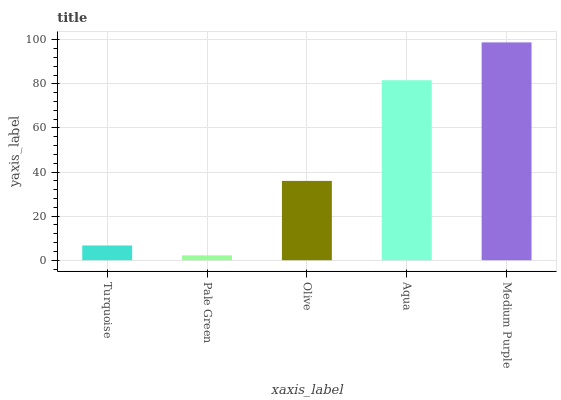Is Pale Green the minimum?
Answer yes or no. Yes. Is Medium Purple the maximum?
Answer yes or no. Yes. Is Olive the minimum?
Answer yes or no. No. Is Olive the maximum?
Answer yes or no. No. Is Olive greater than Pale Green?
Answer yes or no. Yes. Is Pale Green less than Olive?
Answer yes or no. Yes. Is Pale Green greater than Olive?
Answer yes or no. No. Is Olive less than Pale Green?
Answer yes or no. No. Is Olive the high median?
Answer yes or no. Yes. Is Olive the low median?
Answer yes or no. Yes. Is Pale Green the high median?
Answer yes or no. No. Is Turquoise the low median?
Answer yes or no. No. 